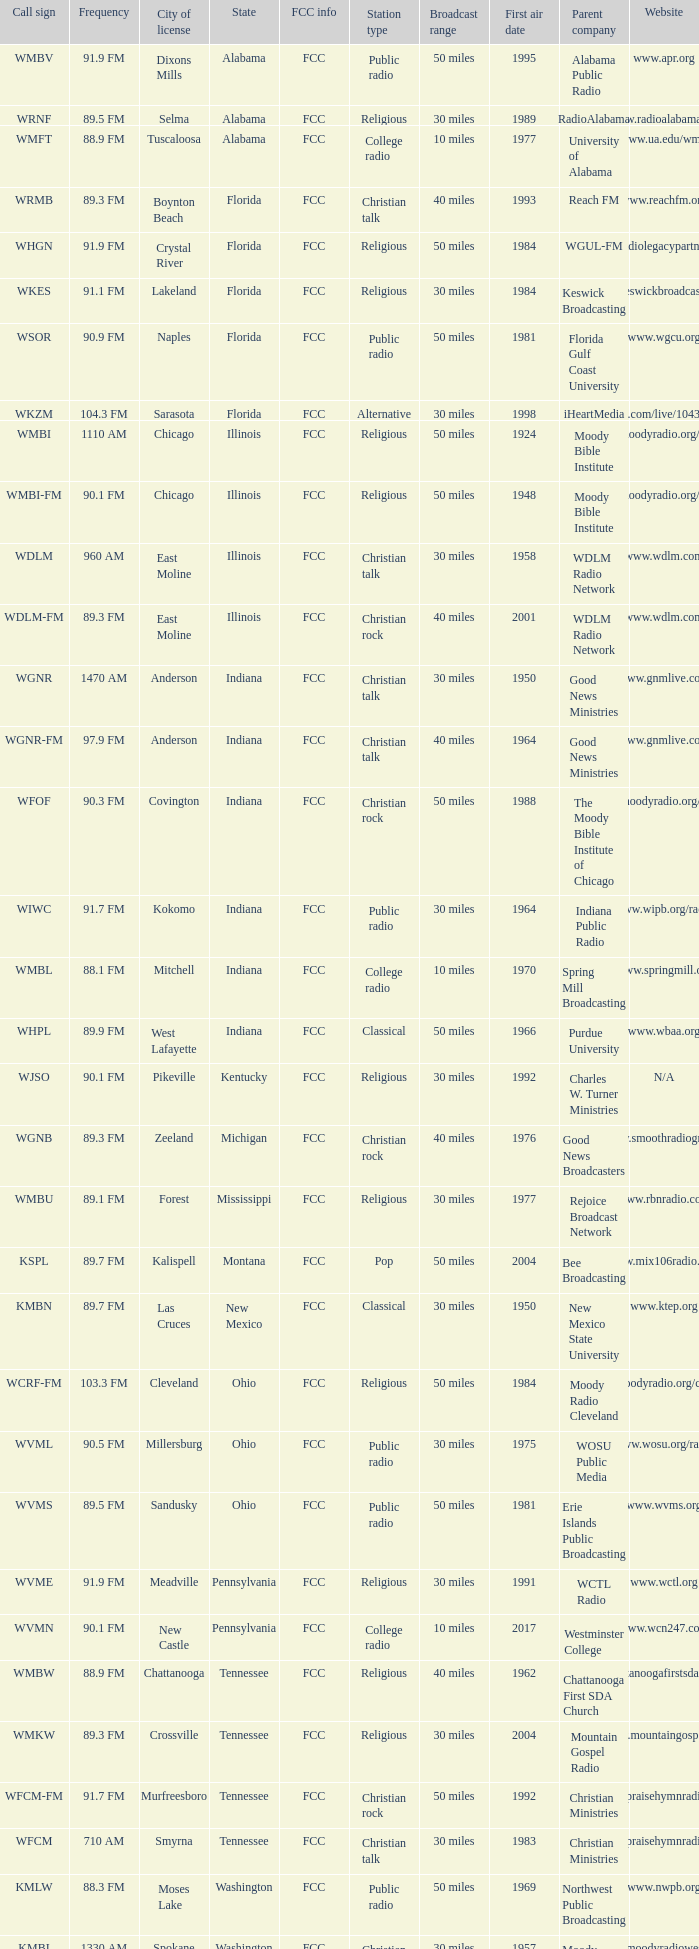At what frequency is the radio station wgnr-fm broadcasted? 97.9 FM. 